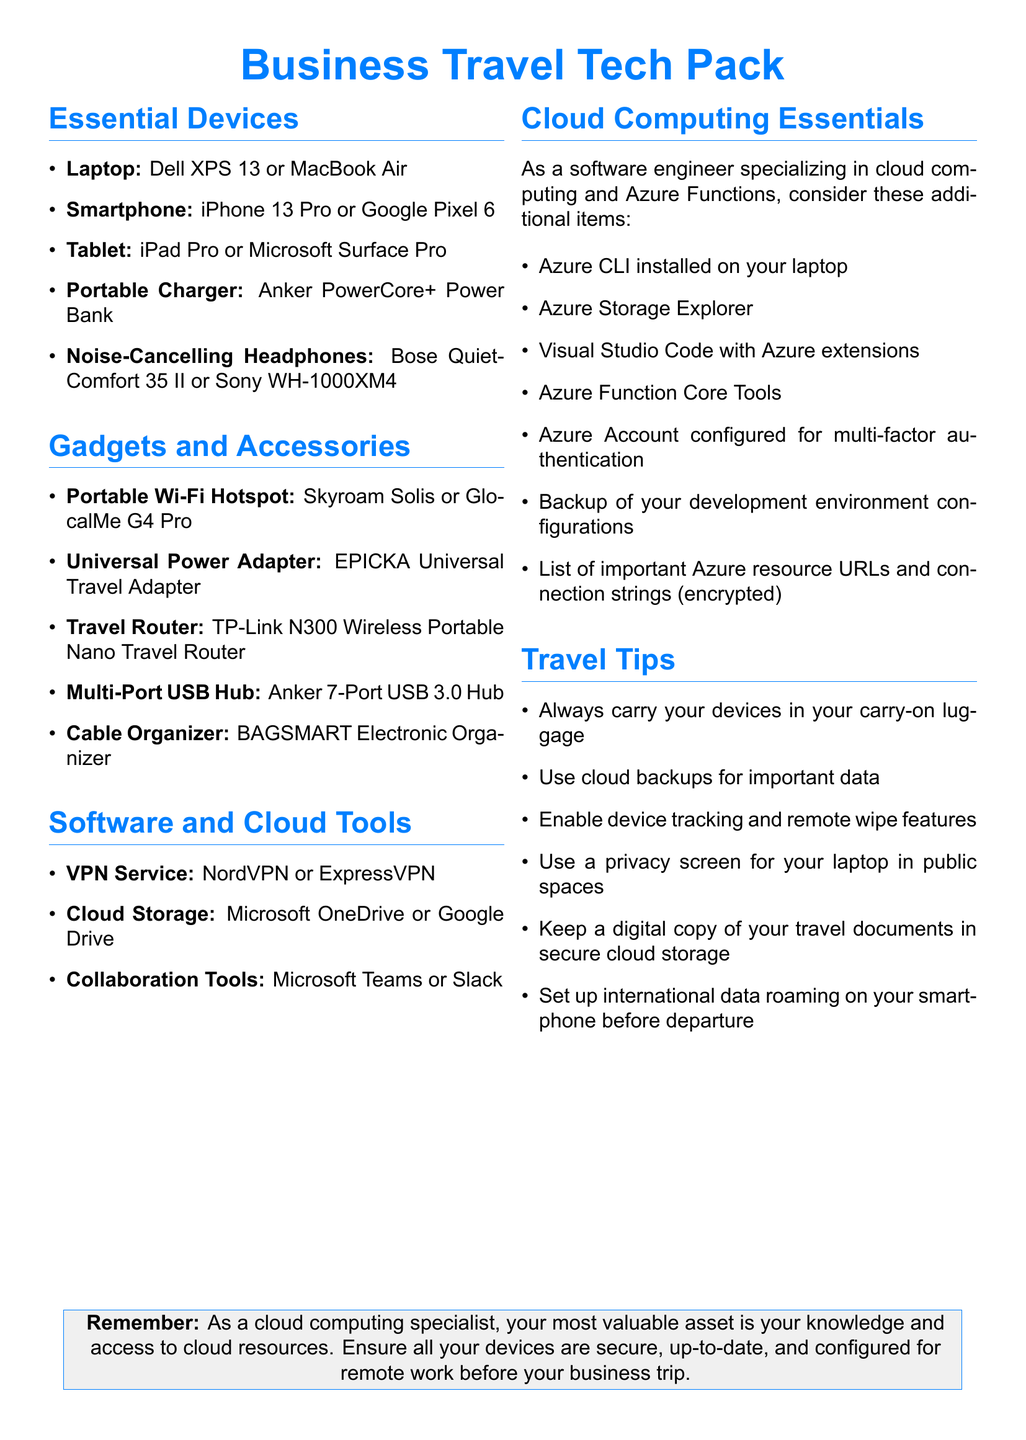what is the recommended laptop? The document specifies two options for laptops: Dell XPS 13 and MacBook Air.
Answer: Dell XPS 13 or MacBook Air which portable charger is suggested? The document suggests using an Anker PowerCore+ Power Bank as the portable charger.
Answer: Anker PowerCore+ Power Bank name one VPN service listed. The document lists NordVPN and ExpressVPN as VPN services.
Answer: NordVPN or ExpressVPN what is an essential tool for cloud computing mentioned? The document includes several tools for cloud computing, one of which is Azure Storage Explorer.
Answer: Azure Storage Explorer how many collaboration tools are listed? The document mentions two collaboration tools: Microsoft Teams and Slack.
Answer: 2 what is one travel tip provided? The document offers several travel tips including carrying devices in carry-on luggage.
Answer: Always carry your devices in your carry-on luggage what should you have configured for multi-factor authentication? The document states that you should have your Azure Account configured for multi-factor authentication.
Answer: Azure Account what is the title of the document? The document is titled "Business Travel Tech Pack."
Answer: Business Travel Tech Pack 